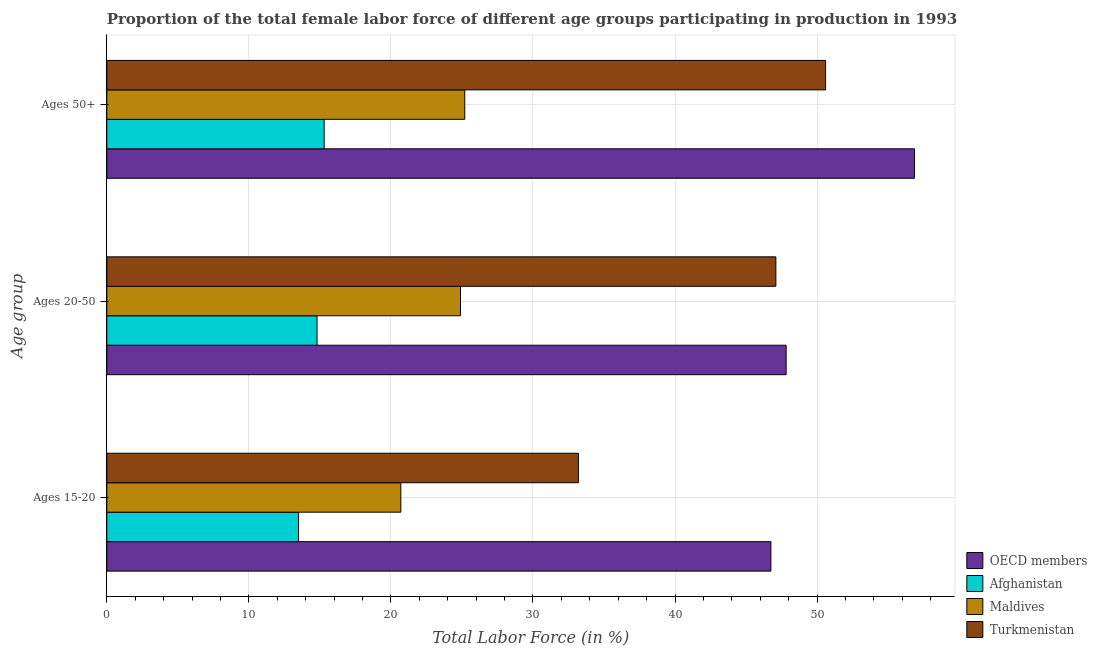How many different coloured bars are there?
Ensure brevity in your answer.  4. How many groups of bars are there?
Provide a succinct answer. 3. Are the number of bars per tick equal to the number of legend labels?
Keep it short and to the point. Yes. Are the number of bars on each tick of the Y-axis equal?
Provide a succinct answer. Yes. How many bars are there on the 2nd tick from the top?
Make the answer very short. 4. How many bars are there on the 3rd tick from the bottom?
Provide a succinct answer. 4. What is the label of the 1st group of bars from the top?
Your answer should be compact. Ages 50+. What is the percentage of female labor force within the age group 15-20 in Maldives?
Give a very brief answer. 20.7. Across all countries, what is the maximum percentage of female labor force above age 50?
Your answer should be very brief. 56.86. Across all countries, what is the minimum percentage of female labor force within the age group 20-50?
Provide a succinct answer. 14.8. In which country was the percentage of female labor force within the age group 15-20 maximum?
Give a very brief answer. OECD members. In which country was the percentage of female labor force within the age group 15-20 minimum?
Give a very brief answer. Afghanistan. What is the total percentage of female labor force above age 50 in the graph?
Give a very brief answer. 147.96. What is the difference between the percentage of female labor force within the age group 15-20 in Maldives and that in OECD members?
Offer a terse response. -26.05. What is the difference between the percentage of female labor force above age 50 in Turkmenistan and the percentage of female labor force within the age group 20-50 in Maldives?
Provide a succinct answer. 25.7. What is the average percentage of female labor force within the age group 15-20 per country?
Give a very brief answer. 28.54. What is the difference between the percentage of female labor force within the age group 15-20 and percentage of female labor force within the age group 20-50 in OECD members?
Offer a terse response. -1.07. What is the ratio of the percentage of female labor force above age 50 in Afghanistan to that in OECD members?
Your answer should be very brief. 0.27. What is the difference between the highest and the second highest percentage of female labor force above age 50?
Give a very brief answer. 6.26. What is the difference between the highest and the lowest percentage of female labor force within the age group 15-20?
Offer a terse response. 33.25. Is the sum of the percentage of female labor force above age 50 in OECD members and Afghanistan greater than the maximum percentage of female labor force within the age group 20-50 across all countries?
Provide a short and direct response. Yes. What does the 2nd bar from the top in Ages 20-50 represents?
Ensure brevity in your answer.  Maldives. What does the 2nd bar from the bottom in Ages 20-50 represents?
Give a very brief answer. Afghanistan. Is it the case that in every country, the sum of the percentage of female labor force within the age group 15-20 and percentage of female labor force within the age group 20-50 is greater than the percentage of female labor force above age 50?
Your response must be concise. Yes. How many bars are there?
Offer a terse response. 12. Are all the bars in the graph horizontal?
Offer a terse response. Yes. What is the difference between two consecutive major ticks on the X-axis?
Keep it short and to the point. 10. Does the graph contain any zero values?
Make the answer very short. No. Does the graph contain grids?
Offer a terse response. Yes. What is the title of the graph?
Keep it short and to the point. Proportion of the total female labor force of different age groups participating in production in 1993. Does "Kazakhstan" appear as one of the legend labels in the graph?
Offer a terse response. No. What is the label or title of the X-axis?
Your answer should be compact. Total Labor Force (in %). What is the label or title of the Y-axis?
Provide a succinct answer. Age group. What is the Total Labor Force (in %) in OECD members in Ages 15-20?
Keep it short and to the point. 46.75. What is the Total Labor Force (in %) of Maldives in Ages 15-20?
Offer a terse response. 20.7. What is the Total Labor Force (in %) of Turkmenistan in Ages 15-20?
Give a very brief answer. 33.2. What is the Total Labor Force (in %) of OECD members in Ages 20-50?
Keep it short and to the point. 47.82. What is the Total Labor Force (in %) in Afghanistan in Ages 20-50?
Your answer should be compact. 14.8. What is the Total Labor Force (in %) in Maldives in Ages 20-50?
Keep it short and to the point. 24.9. What is the Total Labor Force (in %) in Turkmenistan in Ages 20-50?
Give a very brief answer. 47.1. What is the Total Labor Force (in %) of OECD members in Ages 50+?
Your answer should be very brief. 56.86. What is the Total Labor Force (in %) in Afghanistan in Ages 50+?
Make the answer very short. 15.3. What is the Total Labor Force (in %) in Maldives in Ages 50+?
Your answer should be very brief. 25.2. What is the Total Labor Force (in %) of Turkmenistan in Ages 50+?
Offer a very short reply. 50.6. Across all Age group, what is the maximum Total Labor Force (in %) of OECD members?
Provide a succinct answer. 56.86. Across all Age group, what is the maximum Total Labor Force (in %) of Afghanistan?
Offer a very short reply. 15.3. Across all Age group, what is the maximum Total Labor Force (in %) in Maldives?
Offer a very short reply. 25.2. Across all Age group, what is the maximum Total Labor Force (in %) of Turkmenistan?
Make the answer very short. 50.6. Across all Age group, what is the minimum Total Labor Force (in %) of OECD members?
Make the answer very short. 46.75. Across all Age group, what is the minimum Total Labor Force (in %) of Maldives?
Give a very brief answer. 20.7. Across all Age group, what is the minimum Total Labor Force (in %) in Turkmenistan?
Give a very brief answer. 33.2. What is the total Total Labor Force (in %) of OECD members in the graph?
Offer a very short reply. 151.43. What is the total Total Labor Force (in %) of Afghanistan in the graph?
Your answer should be compact. 43.6. What is the total Total Labor Force (in %) in Maldives in the graph?
Make the answer very short. 70.8. What is the total Total Labor Force (in %) in Turkmenistan in the graph?
Ensure brevity in your answer.  130.9. What is the difference between the Total Labor Force (in %) in OECD members in Ages 15-20 and that in Ages 20-50?
Make the answer very short. -1.07. What is the difference between the Total Labor Force (in %) in OECD members in Ages 15-20 and that in Ages 50+?
Ensure brevity in your answer.  -10.11. What is the difference between the Total Labor Force (in %) in Afghanistan in Ages 15-20 and that in Ages 50+?
Offer a terse response. -1.8. What is the difference between the Total Labor Force (in %) in Turkmenistan in Ages 15-20 and that in Ages 50+?
Your response must be concise. -17.4. What is the difference between the Total Labor Force (in %) in OECD members in Ages 20-50 and that in Ages 50+?
Provide a short and direct response. -9.03. What is the difference between the Total Labor Force (in %) of Maldives in Ages 20-50 and that in Ages 50+?
Give a very brief answer. -0.3. What is the difference between the Total Labor Force (in %) in OECD members in Ages 15-20 and the Total Labor Force (in %) in Afghanistan in Ages 20-50?
Your response must be concise. 31.95. What is the difference between the Total Labor Force (in %) of OECD members in Ages 15-20 and the Total Labor Force (in %) of Maldives in Ages 20-50?
Provide a short and direct response. 21.85. What is the difference between the Total Labor Force (in %) of OECD members in Ages 15-20 and the Total Labor Force (in %) of Turkmenistan in Ages 20-50?
Your answer should be very brief. -0.35. What is the difference between the Total Labor Force (in %) in Afghanistan in Ages 15-20 and the Total Labor Force (in %) in Maldives in Ages 20-50?
Give a very brief answer. -11.4. What is the difference between the Total Labor Force (in %) in Afghanistan in Ages 15-20 and the Total Labor Force (in %) in Turkmenistan in Ages 20-50?
Provide a short and direct response. -33.6. What is the difference between the Total Labor Force (in %) in Maldives in Ages 15-20 and the Total Labor Force (in %) in Turkmenistan in Ages 20-50?
Your answer should be compact. -26.4. What is the difference between the Total Labor Force (in %) of OECD members in Ages 15-20 and the Total Labor Force (in %) of Afghanistan in Ages 50+?
Offer a terse response. 31.45. What is the difference between the Total Labor Force (in %) of OECD members in Ages 15-20 and the Total Labor Force (in %) of Maldives in Ages 50+?
Provide a short and direct response. 21.55. What is the difference between the Total Labor Force (in %) of OECD members in Ages 15-20 and the Total Labor Force (in %) of Turkmenistan in Ages 50+?
Give a very brief answer. -3.85. What is the difference between the Total Labor Force (in %) in Afghanistan in Ages 15-20 and the Total Labor Force (in %) in Turkmenistan in Ages 50+?
Provide a succinct answer. -37.1. What is the difference between the Total Labor Force (in %) of Maldives in Ages 15-20 and the Total Labor Force (in %) of Turkmenistan in Ages 50+?
Offer a very short reply. -29.9. What is the difference between the Total Labor Force (in %) of OECD members in Ages 20-50 and the Total Labor Force (in %) of Afghanistan in Ages 50+?
Your answer should be very brief. 32.52. What is the difference between the Total Labor Force (in %) of OECD members in Ages 20-50 and the Total Labor Force (in %) of Maldives in Ages 50+?
Keep it short and to the point. 22.62. What is the difference between the Total Labor Force (in %) in OECD members in Ages 20-50 and the Total Labor Force (in %) in Turkmenistan in Ages 50+?
Make the answer very short. -2.78. What is the difference between the Total Labor Force (in %) of Afghanistan in Ages 20-50 and the Total Labor Force (in %) of Turkmenistan in Ages 50+?
Make the answer very short. -35.8. What is the difference between the Total Labor Force (in %) of Maldives in Ages 20-50 and the Total Labor Force (in %) of Turkmenistan in Ages 50+?
Offer a very short reply. -25.7. What is the average Total Labor Force (in %) in OECD members per Age group?
Your response must be concise. 50.48. What is the average Total Labor Force (in %) in Afghanistan per Age group?
Keep it short and to the point. 14.53. What is the average Total Labor Force (in %) of Maldives per Age group?
Ensure brevity in your answer.  23.6. What is the average Total Labor Force (in %) of Turkmenistan per Age group?
Provide a succinct answer. 43.63. What is the difference between the Total Labor Force (in %) in OECD members and Total Labor Force (in %) in Afghanistan in Ages 15-20?
Keep it short and to the point. 33.25. What is the difference between the Total Labor Force (in %) in OECD members and Total Labor Force (in %) in Maldives in Ages 15-20?
Offer a terse response. 26.05. What is the difference between the Total Labor Force (in %) in OECD members and Total Labor Force (in %) in Turkmenistan in Ages 15-20?
Keep it short and to the point. 13.55. What is the difference between the Total Labor Force (in %) of Afghanistan and Total Labor Force (in %) of Maldives in Ages 15-20?
Your response must be concise. -7.2. What is the difference between the Total Labor Force (in %) of Afghanistan and Total Labor Force (in %) of Turkmenistan in Ages 15-20?
Your answer should be compact. -19.7. What is the difference between the Total Labor Force (in %) of Maldives and Total Labor Force (in %) of Turkmenistan in Ages 15-20?
Your answer should be compact. -12.5. What is the difference between the Total Labor Force (in %) in OECD members and Total Labor Force (in %) in Afghanistan in Ages 20-50?
Offer a terse response. 33.02. What is the difference between the Total Labor Force (in %) in OECD members and Total Labor Force (in %) in Maldives in Ages 20-50?
Provide a succinct answer. 22.92. What is the difference between the Total Labor Force (in %) of OECD members and Total Labor Force (in %) of Turkmenistan in Ages 20-50?
Offer a terse response. 0.72. What is the difference between the Total Labor Force (in %) of Afghanistan and Total Labor Force (in %) of Turkmenistan in Ages 20-50?
Provide a succinct answer. -32.3. What is the difference between the Total Labor Force (in %) of Maldives and Total Labor Force (in %) of Turkmenistan in Ages 20-50?
Provide a succinct answer. -22.2. What is the difference between the Total Labor Force (in %) of OECD members and Total Labor Force (in %) of Afghanistan in Ages 50+?
Keep it short and to the point. 41.56. What is the difference between the Total Labor Force (in %) in OECD members and Total Labor Force (in %) in Maldives in Ages 50+?
Keep it short and to the point. 31.66. What is the difference between the Total Labor Force (in %) of OECD members and Total Labor Force (in %) of Turkmenistan in Ages 50+?
Ensure brevity in your answer.  6.26. What is the difference between the Total Labor Force (in %) in Afghanistan and Total Labor Force (in %) in Turkmenistan in Ages 50+?
Offer a very short reply. -35.3. What is the difference between the Total Labor Force (in %) in Maldives and Total Labor Force (in %) in Turkmenistan in Ages 50+?
Your answer should be very brief. -25.4. What is the ratio of the Total Labor Force (in %) in OECD members in Ages 15-20 to that in Ages 20-50?
Keep it short and to the point. 0.98. What is the ratio of the Total Labor Force (in %) of Afghanistan in Ages 15-20 to that in Ages 20-50?
Give a very brief answer. 0.91. What is the ratio of the Total Labor Force (in %) of Maldives in Ages 15-20 to that in Ages 20-50?
Your answer should be compact. 0.83. What is the ratio of the Total Labor Force (in %) of Turkmenistan in Ages 15-20 to that in Ages 20-50?
Your answer should be very brief. 0.7. What is the ratio of the Total Labor Force (in %) of OECD members in Ages 15-20 to that in Ages 50+?
Your answer should be compact. 0.82. What is the ratio of the Total Labor Force (in %) of Afghanistan in Ages 15-20 to that in Ages 50+?
Make the answer very short. 0.88. What is the ratio of the Total Labor Force (in %) in Maldives in Ages 15-20 to that in Ages 50+?
Keep it short and to the point. 0.82. What is the ratio of the Total Labor Force (in %) of Turkmenistan in Ages 15-20 to that in Ages 50+?
Offer a very short reply. 0.66. What is the ratio of the Total Labor Force (in %) of OECD members in Ages 20-50 to that in Ages 50+?
Provide a succinct answer. 0.84. What is the ratio of the Total Labor Force (in %) of Afghanistan in Ages 20-50 to that in Ages 50+?
Your answer should be very brief. 0.97. What is the ratio of the Total Labor Force (in %) in Maldives in Ages 20-50 to that in Ages 50+?
Offer a terse response. 0.99. What is the ratio of the Total Labor Force (in %) in Turkmenistan in Ages 20-50 to that in Ages 50+?
Offer a very short reply. 0.93. What is the difference between the highest and the second highest Total Labor Force (in %) in OECD members?
Keep it short and to the point. 9.03. What is the difference between the highest and the second highest Total Labor Force (in %) of Turkmenistan?
Provide a succinct answer. 3.5. What is the difference between the highest and the lowest Total Labor Force (in %) of OECD members?
Your response must be concise. 10.11. What is the difference between the highest and the lowest Total Labor Force (in %) of Afghanistan?
Ensure brevity in your answer.  1.8. What is the difference between the highest and the lowest Total Labor Force (in %) in Turkmenistan?
Provide a succinct answer. 17.4. 